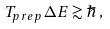Convert formula to latex. <formula><loc_0><loc_0><loc_500><loc_500>T _ { p r e p } \, \Delta E \gtrsim \hbar { \, } ,</formula> 